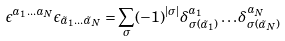<formula> <loc_0><loc_0><loc_500><loc_500>\epsilon ^ { a _ { 1 } \dots a _ { N } } \epsilon _ { \tilde { a } _ { 1 } \dots \tilde { a } _ { N } } = \sum _ { \sigma } ( - 1 ) ^ { | \sigma | } \delta ^ { a _ { 1 } } _ { \sigma ( \tilde { a } _ { 1 } ) } \dots \delta ^ { a _ { N } } _ { \sigma ( \tilde { a } _ { N } ) }</formula> 